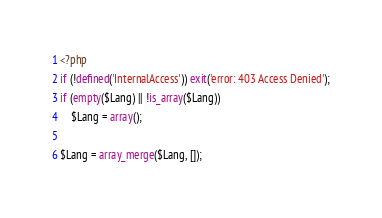Convert code to text. <code><loc_0><loc_0><loc_500><loc_500><_PHP_><?php
if (!defined('InternalAccess')) exit('error: 403 Access Denied');
if (empty($Lang) || !is_array($Lang))
	$Lang = array();

$Lang = array_merge($Lang, []);</code> 